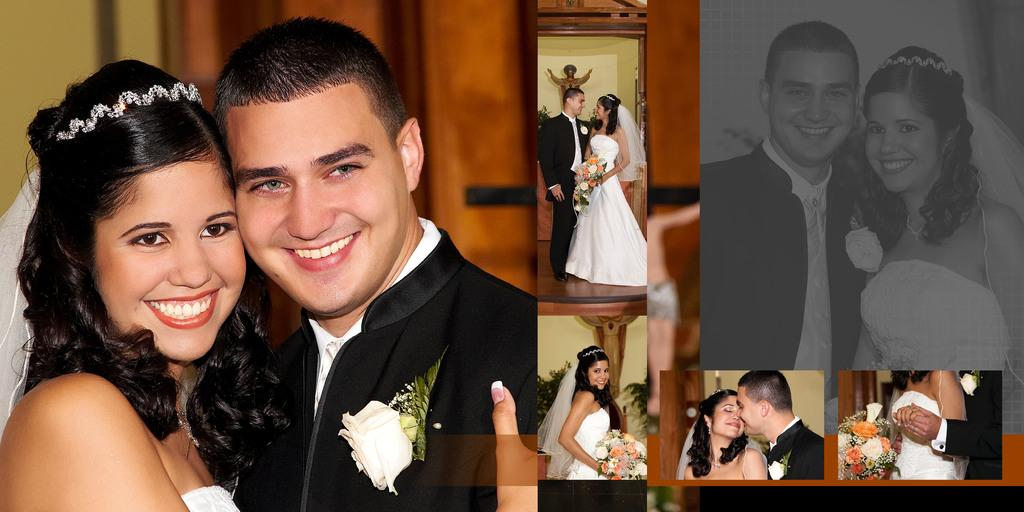How many people are present in the image? There are two people, a person and a woman, present in the image. What are the people holding in the image? The people are holding a flower bouquet. What can be seen in the background of the image? There is a statue, plants, a wall, and a door in the background of the image. What is the tendency of the water in the image? There is no water present in the image, so it is not possible to determine any tendencies related to water. 